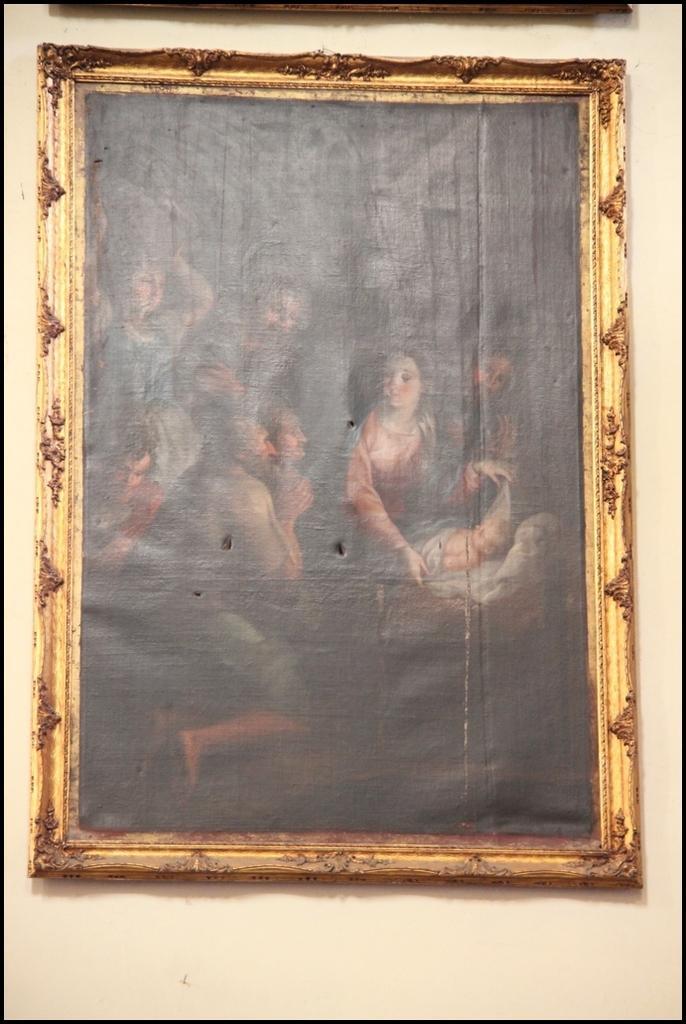How would you summarize this image in a sentence or two? It is a photograph in a photo frame, in this a woman is there. There are men in the left side of an image. 